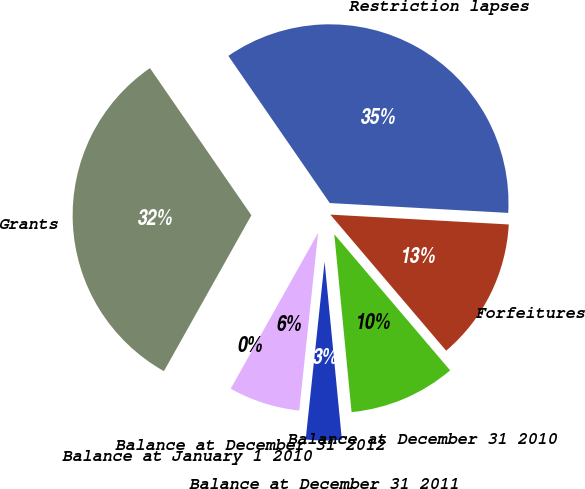Convert chart to OTSL. <chart><loc_0><loc_0><loc_500><loc_500><pie_chart><fcel>Balance at January 1 2010<fcel>Grants<fcel>Restriction lapses<fcel>Forfeitures<fcel>Balance at December 31 2010<fcel>Balance at December 31 2011<fcel>Balance at December 31 2012<nl><fcel>0.0%<fcel>32.26%<fcel>35.48%<fcel>12.9%<fcel>9.68%<fcel>3.23%<fcel>6.45%<nl></chart> 